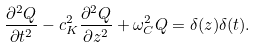<formula> <loc_0><loc_0><loc_500><loc_500>\frac { \partial ^ { 2 } Q } { \partial t ^ { 2 } } - c _ { K } ^ { 2 } \frac { \partial ^ { 2 } Q } { \partial z ^ { 2 } } + \omega _ { C } ^ { 2 } Q = \delta ( z ) \delta ( t ) .</formula> 